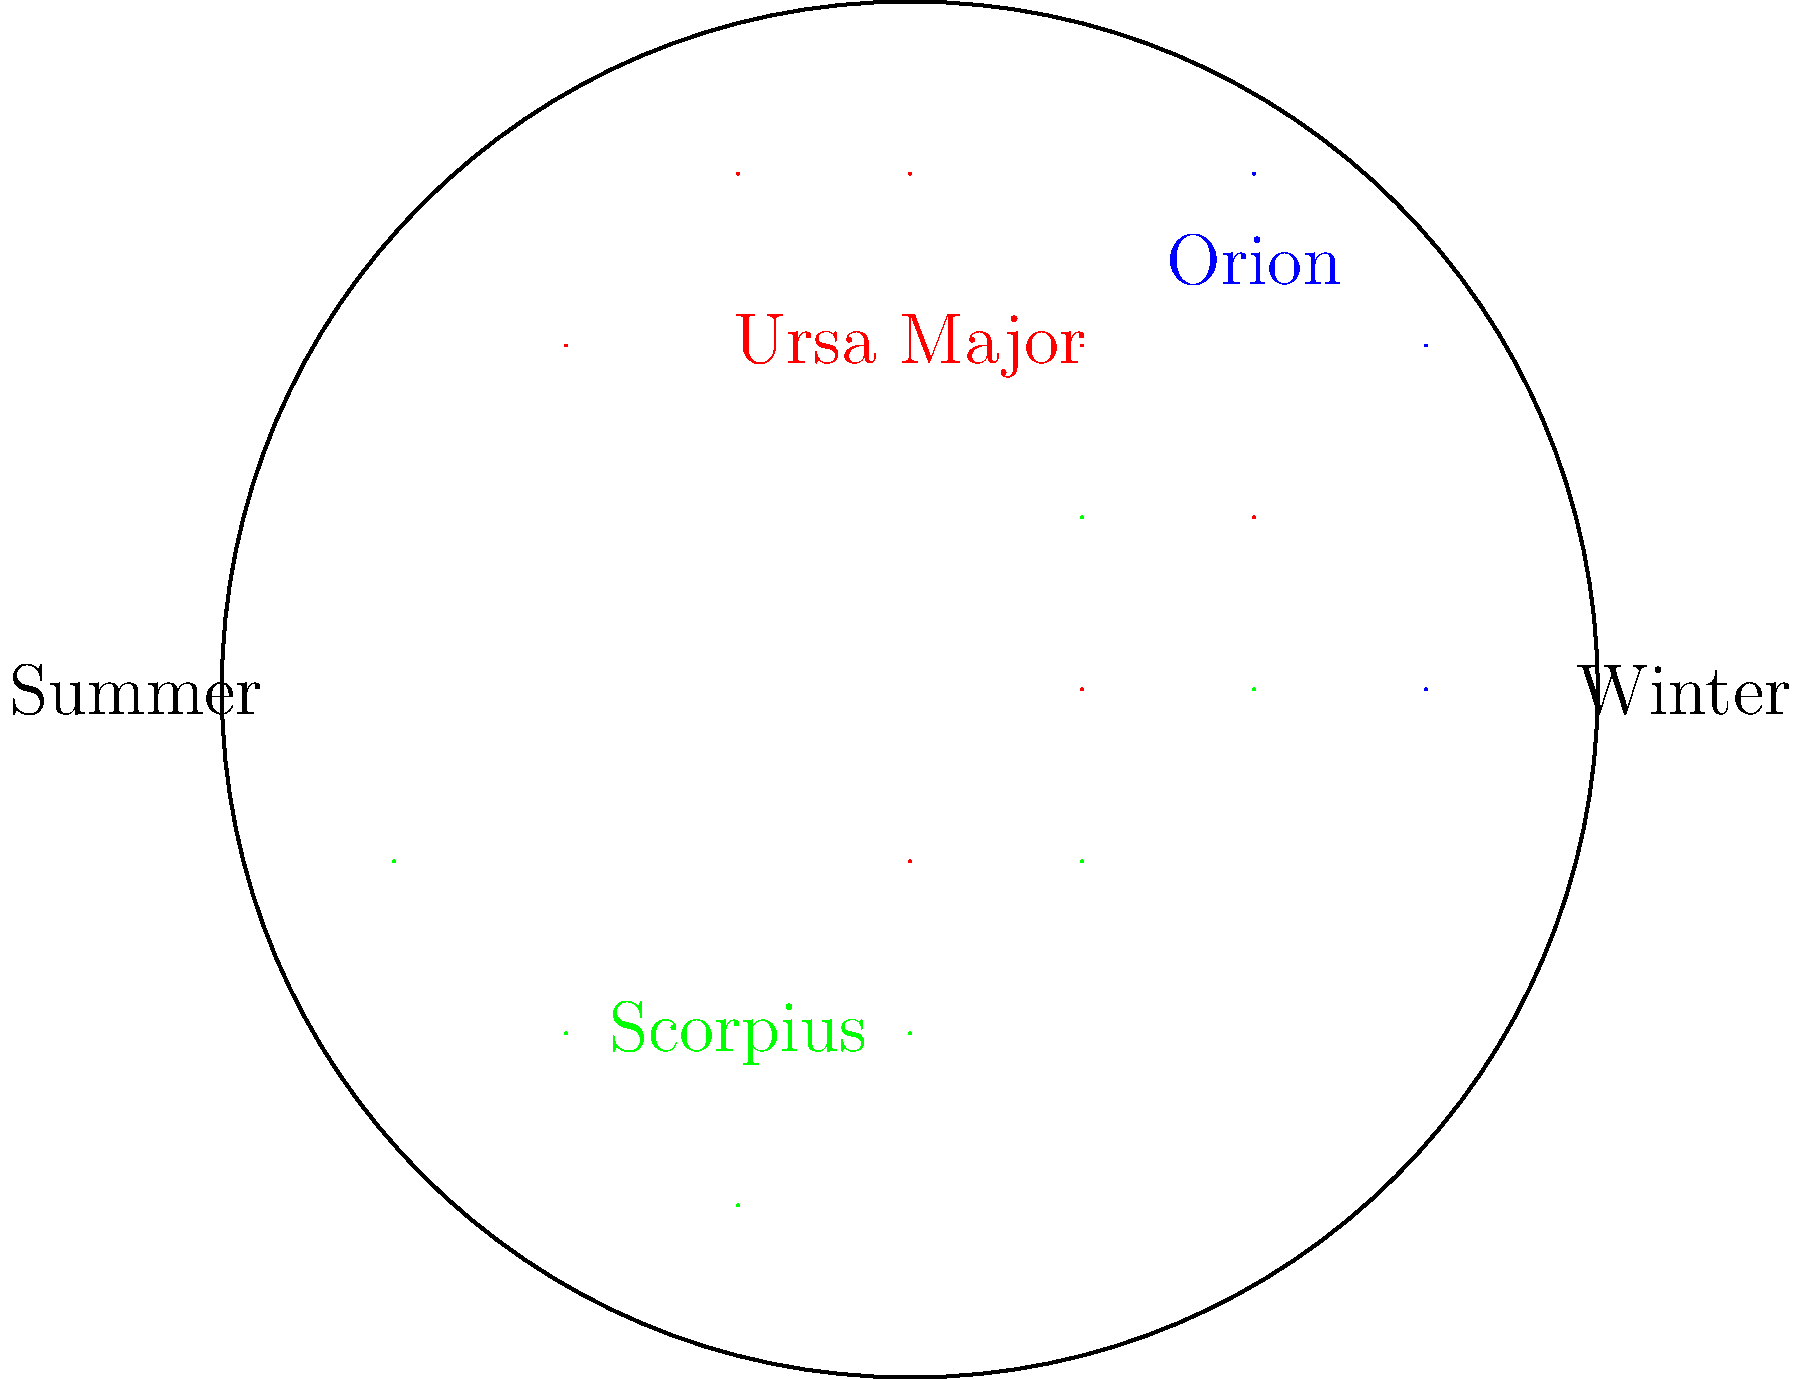Which constellation in Tampa's night sky is visible year-round and can help you locate the North Star? To answer this question, let's consider the following steps:

1. Tampa's location: Tampa is in the Northern Hemisphere, at approximately 28°N latitude.

2. Circumpolar constellations: These are constellations that never set below the horizon from a given location. They appear to rotate around the celestial pole.

3. Visible constellations in Tampa:
   - Winter: Orion is prominent
   - Summer: Scorpius is visible
   - Year-round: Ursa Major (Big Dipper) is circumpolar

4. Ursa Major and the North Star:
   - Ursa Major contains the Big Dipper asterism
   - The two stars at the front edge of the Big Dipper's bowl point to Polaris, the North Star
   - This makes Ursa Major an excellent tool for finding true north

5. Importance for Tampa residents:
   - As frequent city-goers, knowing how to find north can be useful for navigation during nighttime outings or getaways

Therefore, Ursa Major is the constellation that is visible year-round in Tampa and can help locate the North Star.
Answer: Ursa Major 